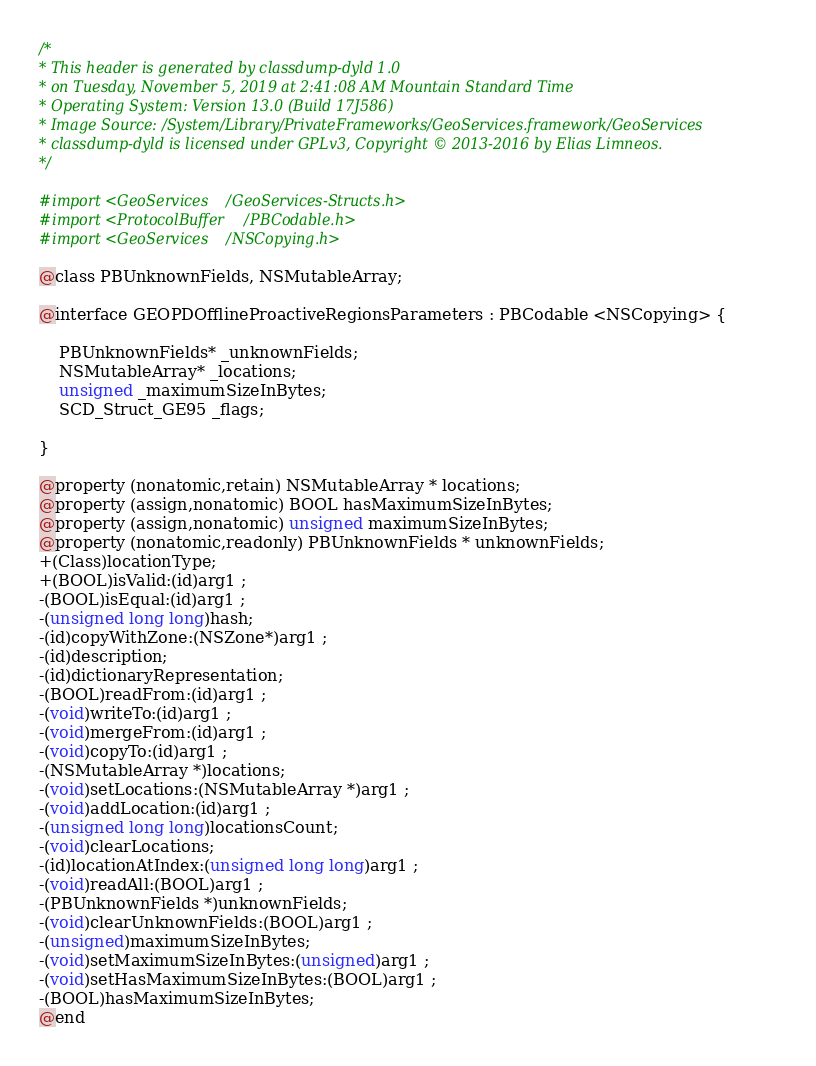Convert code to text. <code><loc_0><loc_0><loc_500><loc_500><_C_>/*
* This header is generated by classdump-dyld 1.0
* on Tuesday, November 5, 2019 at 2:41:08 AM Mountain Standard Time
* Operating System: Version 13.0 (Build 17J586)
* Image Source: /System/Library/PrivateFrameworks/GeoServices.framework/GeoServices
* classdump-dyld is licensed under GPLv3, Copyright © 2013-2016 by Elias Limneos.
*/

#import <GeoServices/GeoServices-Structs.h>
#import <ProtocolBuffer/PBCodable.h>
#import <GeoServices/NSCopying.h>

@class PBUnknownFields, NSMutableArray;

@interface GEOPDOfflineProactiveRegionsParameters : PBCodable <NSCopying> {

	PBUnknownFields* _unknownFields;
	NSMutableArray* _locations;
	unsigned _maximumSizeInBytes;
	SCD_Struct_GE95 _flags;

}

@property (nonatomic,retain) NSMutableArray * locations; 
@property (assign,nonatomic) BOOL hasMaximumSizeInBytes; 
@property (assign,nonatomic) unsigned maximumSizeInBytes; 
@property (nonatomic,readonly) PBUnknownFields * unknownFields; 
+(Class)locationType;
+(BOOL)isValid:(id)arg1 ;
-(BOOL)isEqual:(id)arg1 ;
-(unsigned long long)hash;
-(id)copyWithZone:(NSZone*)arg1 ;
-(id)description;
-(id)dictionaryRepresentation;
-(BOOL)readFrom:(id)arg1 ;
-(void)writeTo:(id)arg1 ;
-(void)mergeFrom:(id)arg1 ;
-(void)copyTo:(id)arg1 ;
-(NSMutableArray *)locations;
-(void)setLocations:(NSMutableArray *)arg1 ;
-(void)addLocation:(id)arg1 ;
-(unsigned long long)locationsCount;
-(void)clearLocations;
-(id)locationAtIndex:(unsigned long long)arg1 ;
-(void)readAll:(BOOL)arg1 ;
-(PBUnknownFields *)unknownFields;
-(void)clearUnknownFields:(BOOL)arg1 ;
-(unsigned)maximumSizeInBytes;
-(void)setMaximumSizeInBytes:(unsigned)arg1 ;
-(void)setHasMaximumSizeInBytes:(BOOL)arg1 ;
-(BOOL)hasMaximumSizeInBytes;
@end

</code> 